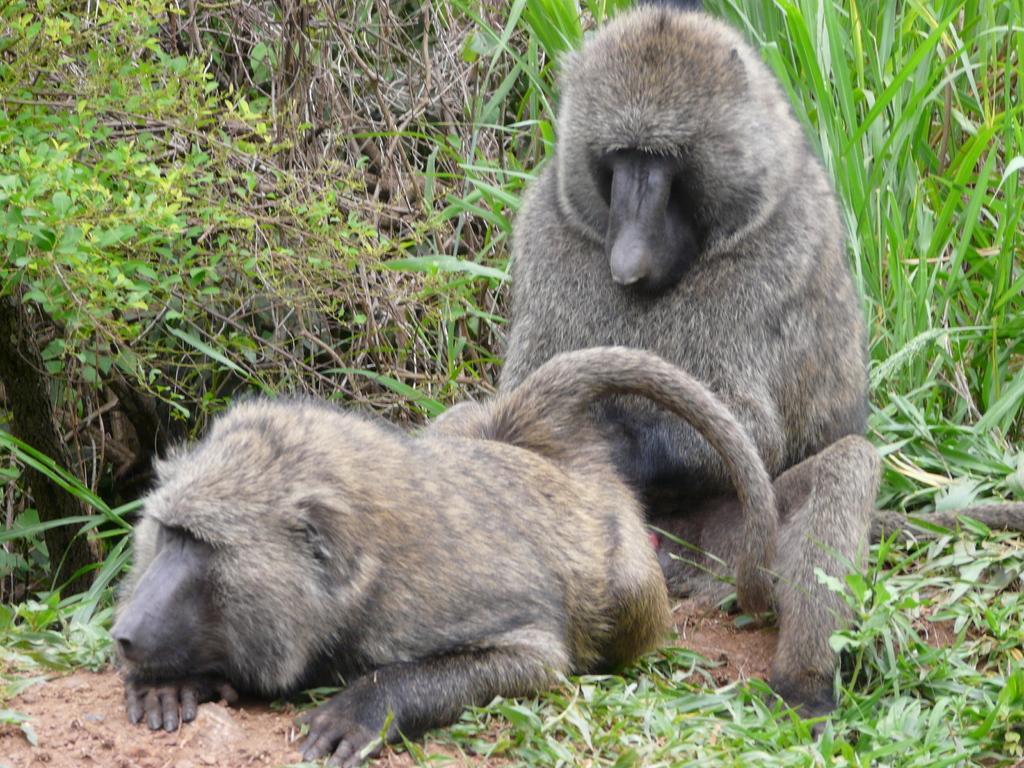Can you describe this image briefly? In this image we can see two monkeys, some bushes, plants and grass on the surface. 